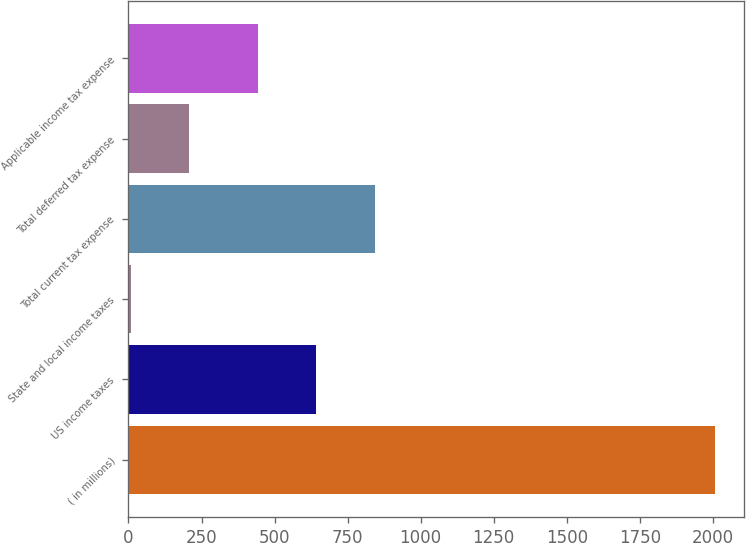Convert chart to OTSL. <chart><loc_0><loc_0><loc_500><loc_500><bar_chart><fcel>( in millions)<fcel>US income taxes<fcel>State and local income taxes<fcel>Total current tax expense<fcel>Total deferred tax expense<fcel>Applicable income tax expense<nl><fcel>2006<fcel>642.9<fcel>7<fcel>842.8<fcel>206.9<fcel>443<nl></chart> 